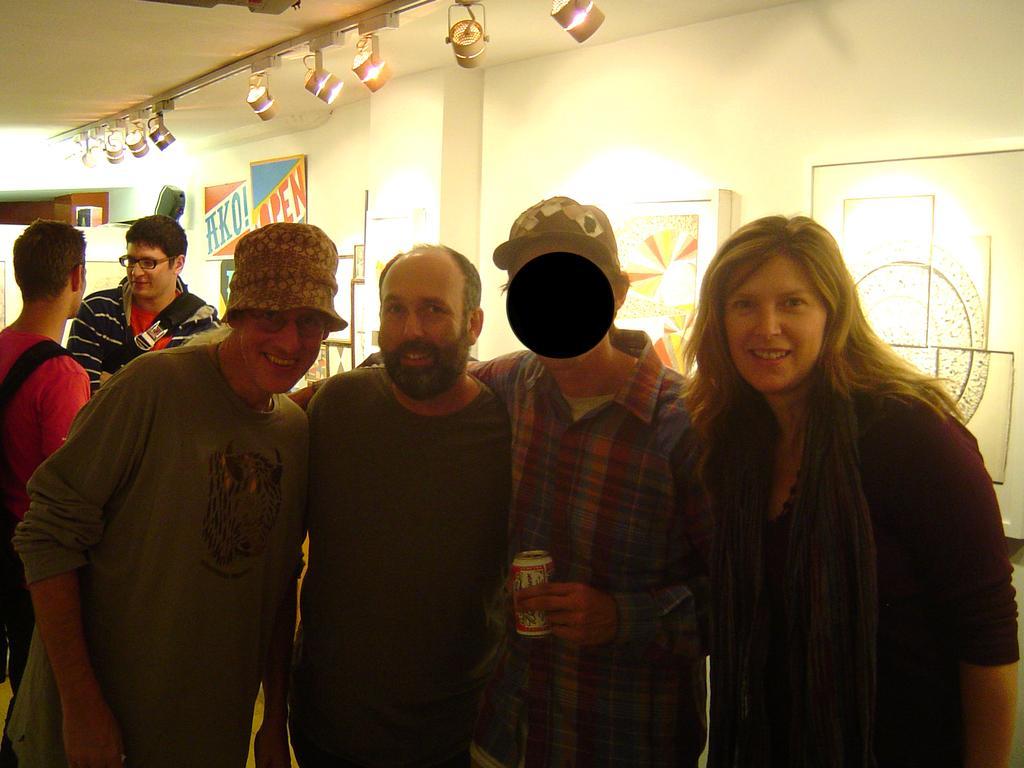In one or two sentences, can you explain what this image depicts? In this image I can see three men and a woman wearing black dress are standing and I can see a man is holding a tin in his hand. In the background I can see two other persons standing, the ceiling, few lights attached to the ceiling, the cream colored wall, few photo frames attached to the wall and few other objects. 